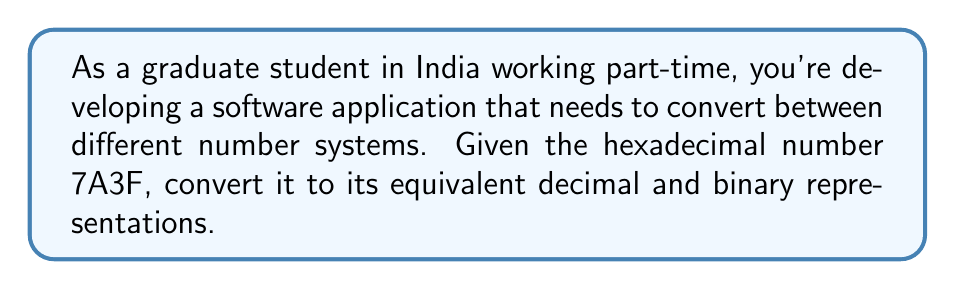Show me your answer to this math problem. Let's approach this step-by-step:

1. Converting hexadecimal to decimal:
   The hexadecimal number 7A3F can be expanded as:
   
   $7A3F_{16} = 7 \times 16^3 + 10 \times 16^2 + 3 \times 16^1 + 15 \times 16^0$

   Note that A = 10 and F = 15 in hexadecimal.

   $= 7 \times 4096 + 10 \times 256 + 3 \times 16 + 15 \times 1$
   $= 28672 + 2560 + 48 + 15$
   $= 31295_{10}$

2. Converting decimal to binary:
   We can convert 31295 to binary by repeatedly dividing by 2 and keeping track of the remainders:

   $$
   \begin{array}{r|l}
   31295 \div 2 = 15647 & \text{remainder } 1 \\
   15647 \div 2 = 7823 & \text{remainder } 1 \\
   7823 \div 2 = 3911 & \text{remainder } 1 \\
   3911 \div 2 = 1955 & \text{remainder } 1 \\
   1955 \div 2 = 977 & \text{remainder } 1 \\
   977 \div 2 = 488 & \text{remainder } 1 \\
   488 \div 2 = 244 & \text{remainder } 0 \\
   244 \div 2 = 122 & \text{remainder } 0 \\
   122 \div 2 = 61 & \text{remainder } 0 \\
   61 \div 2 = 30 & \text{remainder } 1 \\
   30 \div 2 = 15 & \text{remainder } 0 \\
   15 \div 2 = 7 & \text{remainder } 1 \\
   7 \div 2 = 3 & \text{remainder } 1 \\
   3 \div 2 = 1 & \text{remainder } 1 \\
   1 \div 2 = 0 & \text{remainder } 1
   \end{array}
   $$

   Reading the remainders from bottom to top gives us the binary number:
   $111101000111111_2$

Therefore, $7A3F_{16} = 31295_{10} = 111101000111111_2$
Answer: Decimal: $31295_{10}$
Binary: $111101000111111_2$ 